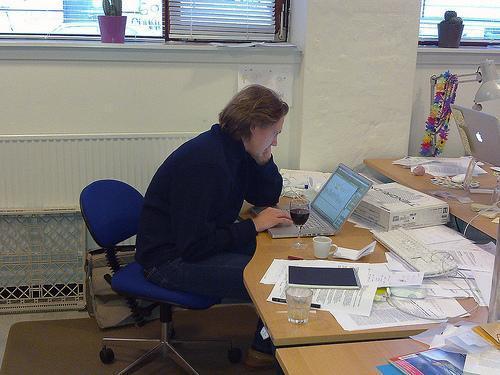How many people are in this picture?
Give a very brief answer. 1. 